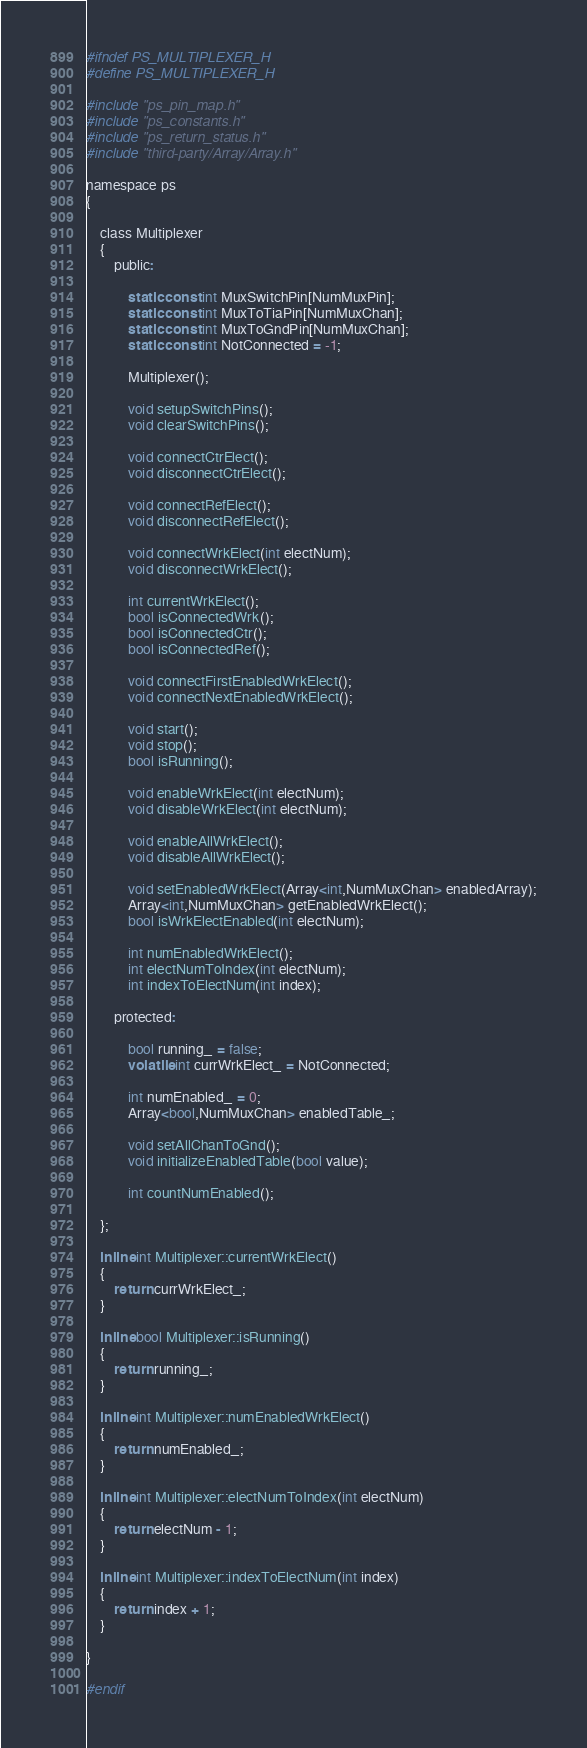<code> <loc_0><loc_0><loc_500><loc_500><_C_>#ifndef PS_MULTIPLEXER_H
#define PS_MULTIPLEXER_H

#include "ps_pin_map.h"
#include "ps_constants.h"
#include "ps_return_status.h"
#include "third-party/Array/Array.h"

namespace ps
{

    class Multiplexer
    {
        public:

            static const int MuxSwitchPin[NumMuxPin]; 
            static const int MuxToTiaPin[NumMuxChan];
            static const int MuxToGndPin[NumMuxChan];
            static const int NotConnected = -1;

            Multiplexer();

            void setupSwitchPins();
            void clearSwitchPins();

            void connectCtrElect();
            void disconnectCtrElect();

            void connectRefElect();
            void disconnectRefElect();

            void connectWrkElect(int electNum);
            void disconnectWrkElect();

            int currentWrkElect();
            bool isConnectedWrk();
            bool isConnectedCtr();
            bool isConnectedRef();

            void connectFirstEnabledWrkElect();
            void connectNextEnabledWrkElect();   

            void start();  
            void stop();
            bool isRunning();

            void enableWrkElect(int electNum);
            void disableWrkElect(int electNum);

            void enableAllWrkElect();
            void disableAllWrkElect();

            void setEnabledWrkElect(Array<int,NumMuxChan> enabledArray);
            Array<int,NumMuxChan> getEnabledWrkElect();
            bool isWrkElectEnabled(int electNum);

            int numEnabledWrkElect();
            int electNumToIndex(int electNum);
            int indexToElectNum(int index);

        protected:

            bool running_ = false;
            volatile int currWrkElect_ = NotConnected;

            int numEnabled_ = 0;
            Array<bool,NumMuxChan> enabledTable_;

            void setAllChanToGnd();
            void initializeEnabledTable(bool value);

            int countNumEnabled();

    };

    inline int Multiplexer::currentWrkElect()
    {
        return currWrkElect_;
    }

    inline bool Multiplexer::isRunning()
    {
        return running_;
    }

    inline int Multiplexer::numEnabledWrkElect()
    {
        return numEnabled_;
    }

    inline int Multiplexer::electNumToIndex(int electNum)
    {
        return electNum - 1;
    }

    inline int Multiplexer::indexToElectNum(int index)
    {
        return index + 1;
    }

}

#endif
</code> 